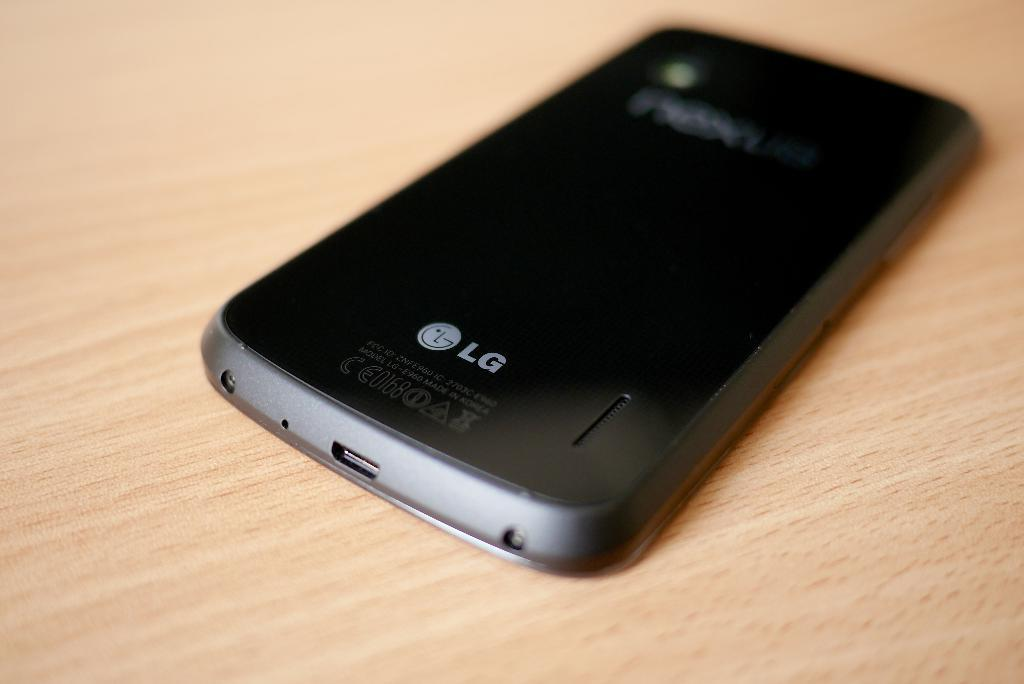<image>
Write a terse but informative summary of the picture. A black phone rests on the table and the make is LG. 